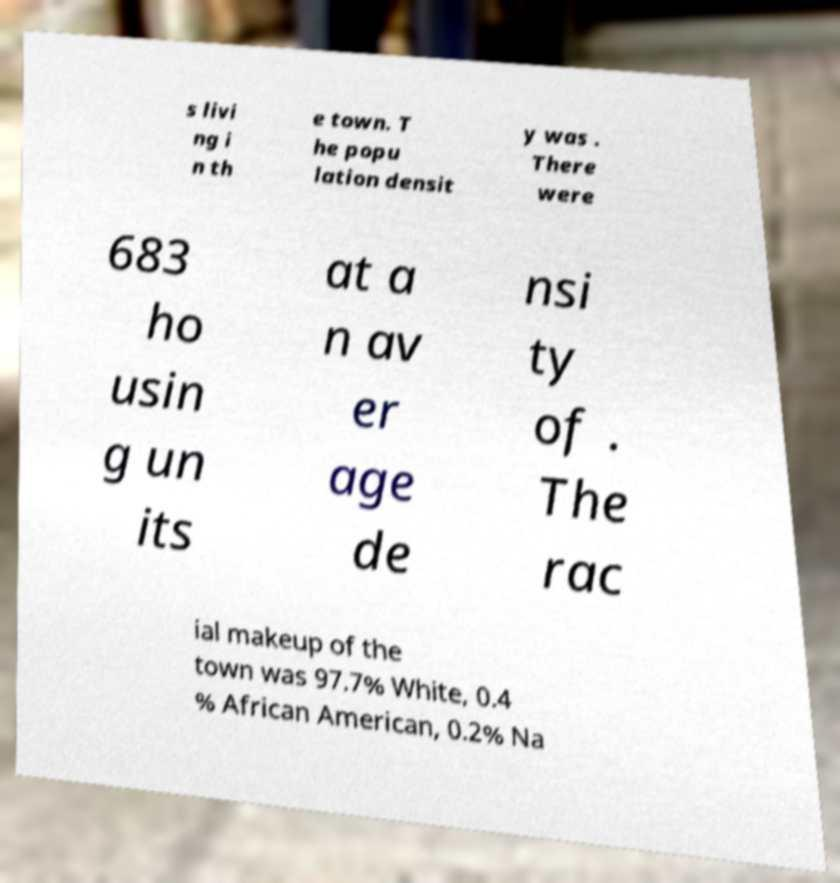There's text embedded in this image that I need extracted. Can you transcribe it verbatim? s livi ng i n th e town. T he popu lation densit y was . There were 683 ho usin g un its at a n av er age de nsi ty of . The rac ial makeup of the town was 97.7% White, 0.4 % African American, 0.2% Na 